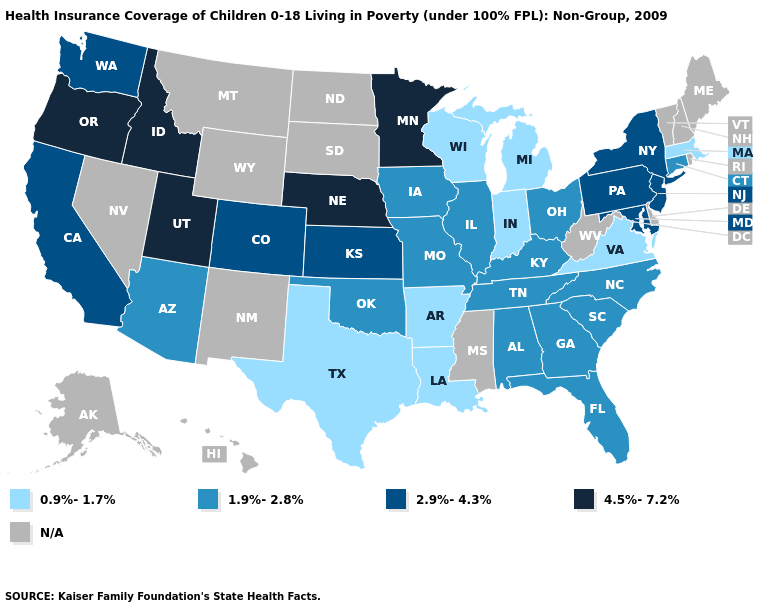What is the highest value in states that border Ohio?
Give a very brief answer. 2.9%-4.3%. What is the lowest value in states that border Michigan?
Short answer required. 0.9%-1.7%. What is the value of Wyoming?
Short answer required. N/A. Name the states that have a value in the range 4.5%-7.2%?
Keep it brief. Idaho, Minnesota, Nebraska, Oregon, Utah. Is the legend a continuous bar?
Keep it brief. No. What is the highest value in the USA?
Quick response, please. 4.5%-7.2%. Name the states that have a value in the range 0.9%-1.7%?
Short answer required. Arkansas, Indiana, Louisiana, Massachusetts, Michigan, Texas, Virginia, Wisconsin. Does the map have missing data?
Quick response, please. Yes. Which states hav the highest value in the West?
Short answer required. Idaho, Oregon, Utah. Among the states that border Maryland , which have the lowest value?
Quick response, please. Virginia. Which states have the highest value in the USA?
Answer briefly. Idaho, Minnesota, Nebraska, Oregon, Utah. What is the value of Florida?
Keep it brief. 1.9%-2.8%. What is the highest value in the USA?
Be succinct. 4.5%-7.2%. 